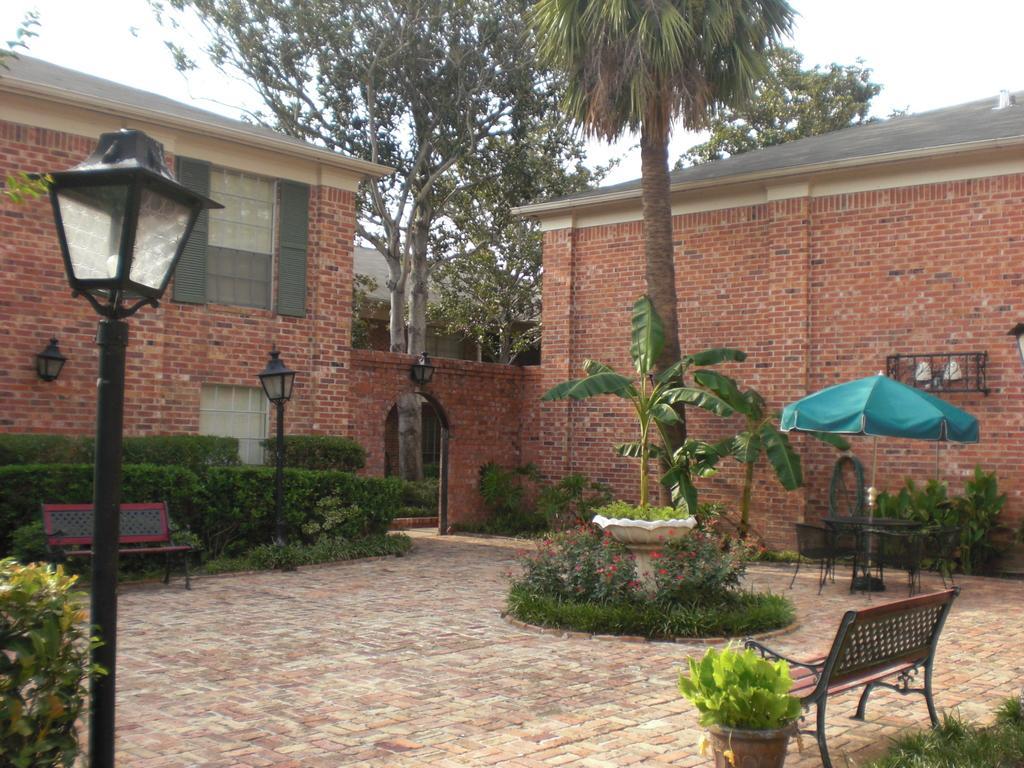Can you describe this image briefly? In this picture we see couple of houses, few trees and a umbrella few chairs and two benches and a couple of pole lights 